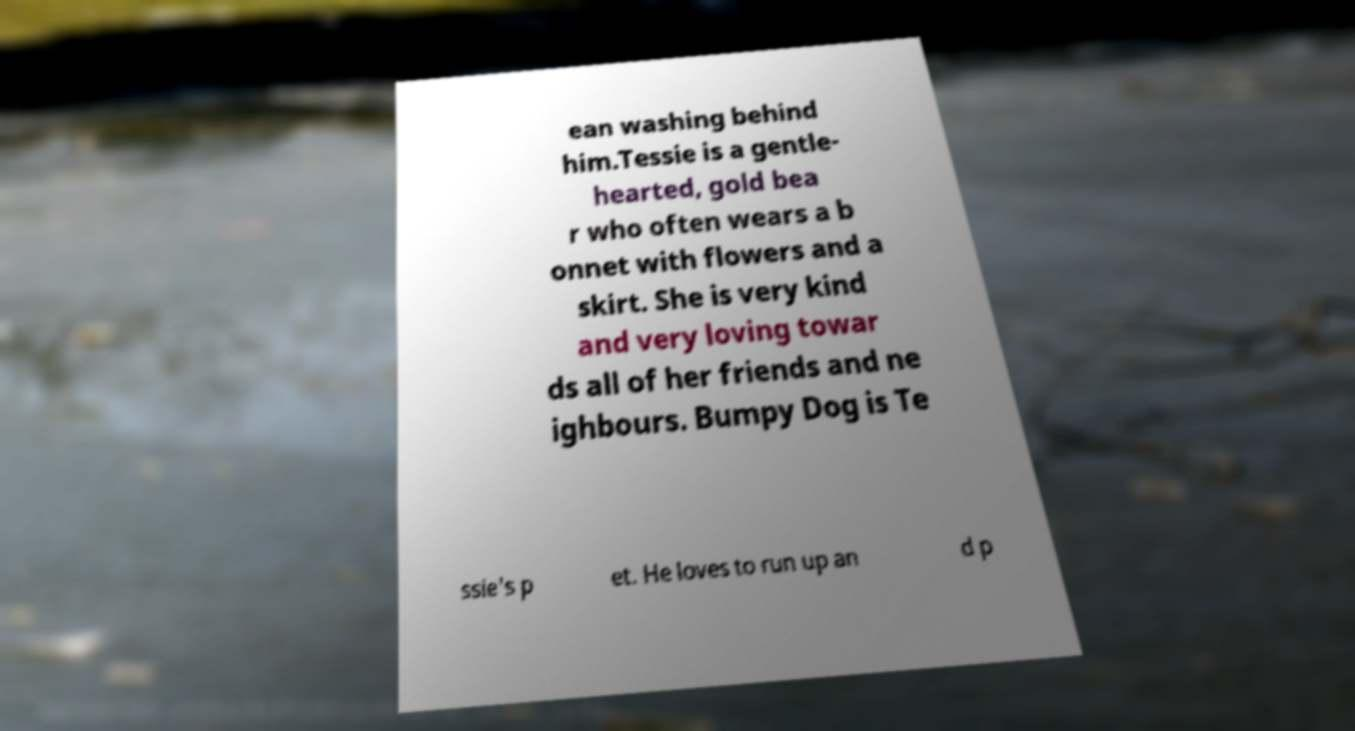Could you extract and type out the text from this image? ean washing behind him.Tessie is a gentle- hearted, gold bea r who often wears a b onnet with flowers and a skirt. She is very kind and very loving towar ds all of her friends and ne ighbours. Bumpy Dog is Te ssie's p et. He loves to run up an d p 